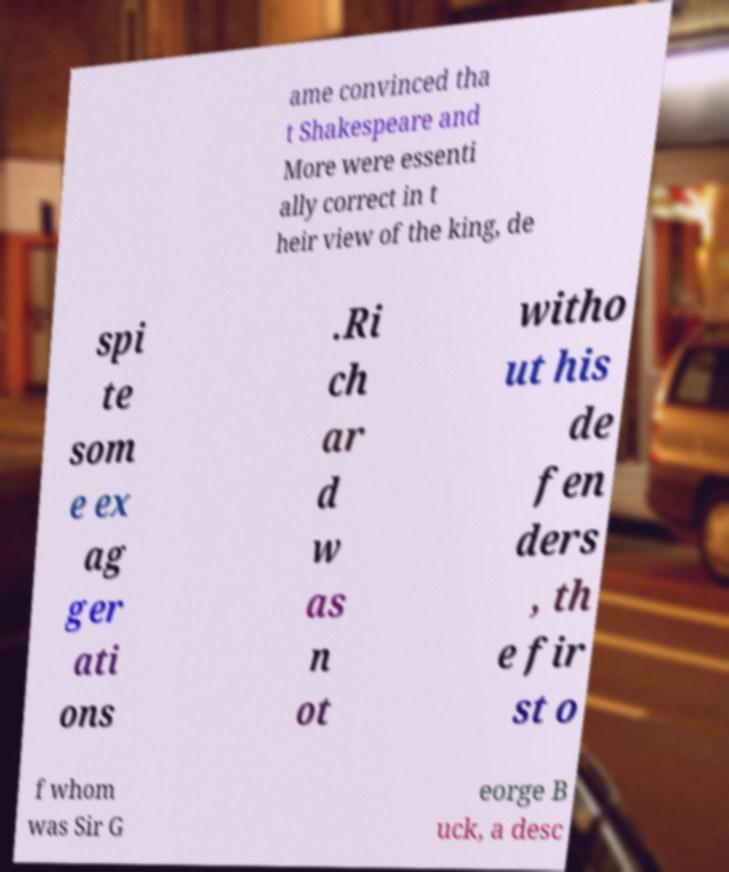Could you extract and type out the text from this image? ame convinced tha t Shakespeare and More were essenti ally correct in t heir view of the king, de spi te som e ex ag ger ati ons .Ri ch ar d w as n ot witho ut his de fen ders , th e fir st o f whom was Sir G eorge B uck, a desc 